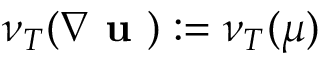<formula> <loc_0><loc_0><loc_500><loc_500>\nu _ { T } ( \nabla u ) \colon = \nu _ { T } ( \mu )</formula> 